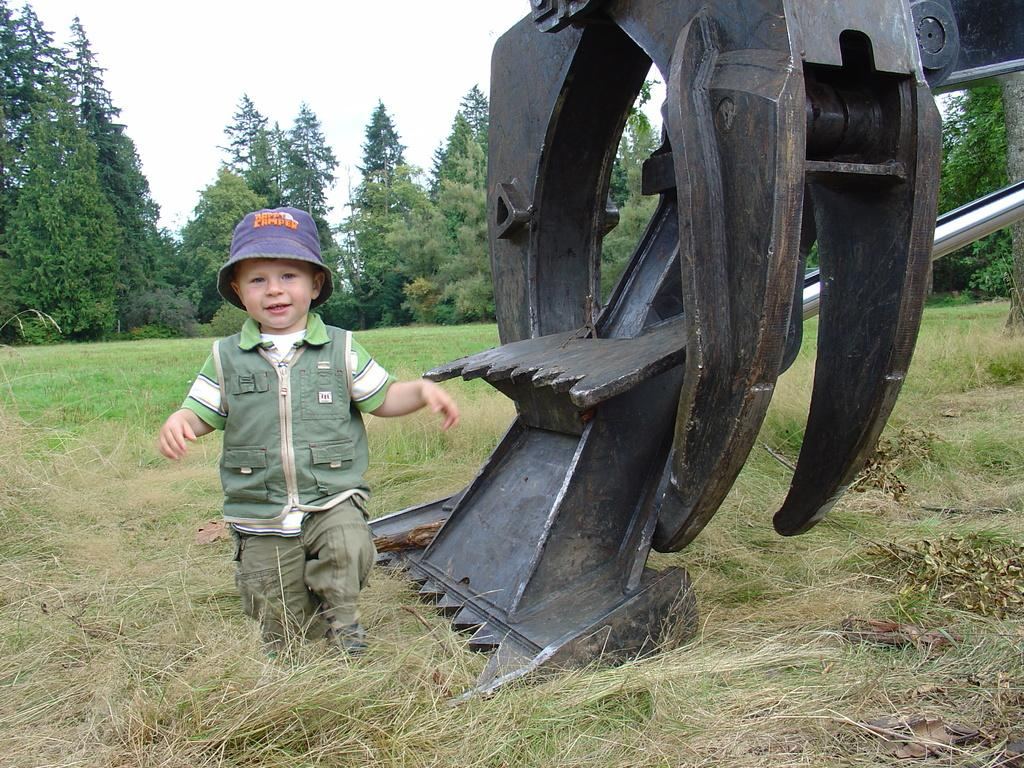What is the main subject of the image? The main subject of the image is a kid. What is the kid doing in the image? The kid is walking on the ground in the image. What can be seen beside the kid? There is a crane beside the kid in the image. What type of vegetation is visible in the background of the image? There are trees in the background of the image. What is the ground made of in the image? The ground is made of grass, which can be seen at the bottom of the image. What is the taste of the army in the image? There is no army present in the image, and therefore no taste can be associated with it. Does the kid have a tail in the image? The kid does not have a tail in the image. 